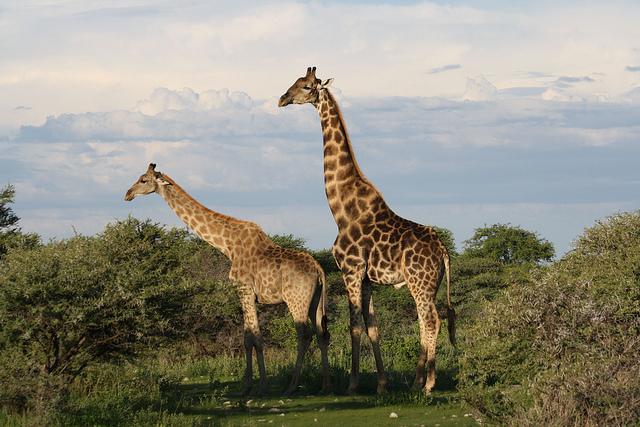Are there any clouds in the sky?
Give a very brief answer. Yes. Where is this picture taken?
Give a very brief answer. Africa. What is the baby giraffe drawing from its mother?
Concise answer only. Nothing. Are the giraffes eating from the tree?
Give a very brief answer. No. What is the animal in the scene doing?
Concise answer only. Standing. Would the smaller animals be able to easily walk underneath the larger animals?
Concise answer only. No. Is the giraffe taller than the tree?
Quick response, please. Yes. How many giraffes in the field?
Write a very short answer. 2. Which giraffe is the male?
Be succinct. One on right. How many giraffes are there?
Write a very short answer. 2. Which giraffe is taller?
Be succinct. Right. How many giraffes are in the photo?
Be succinct. 2. 